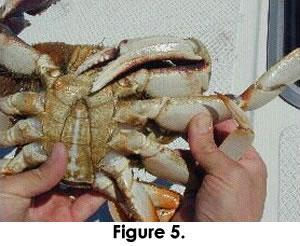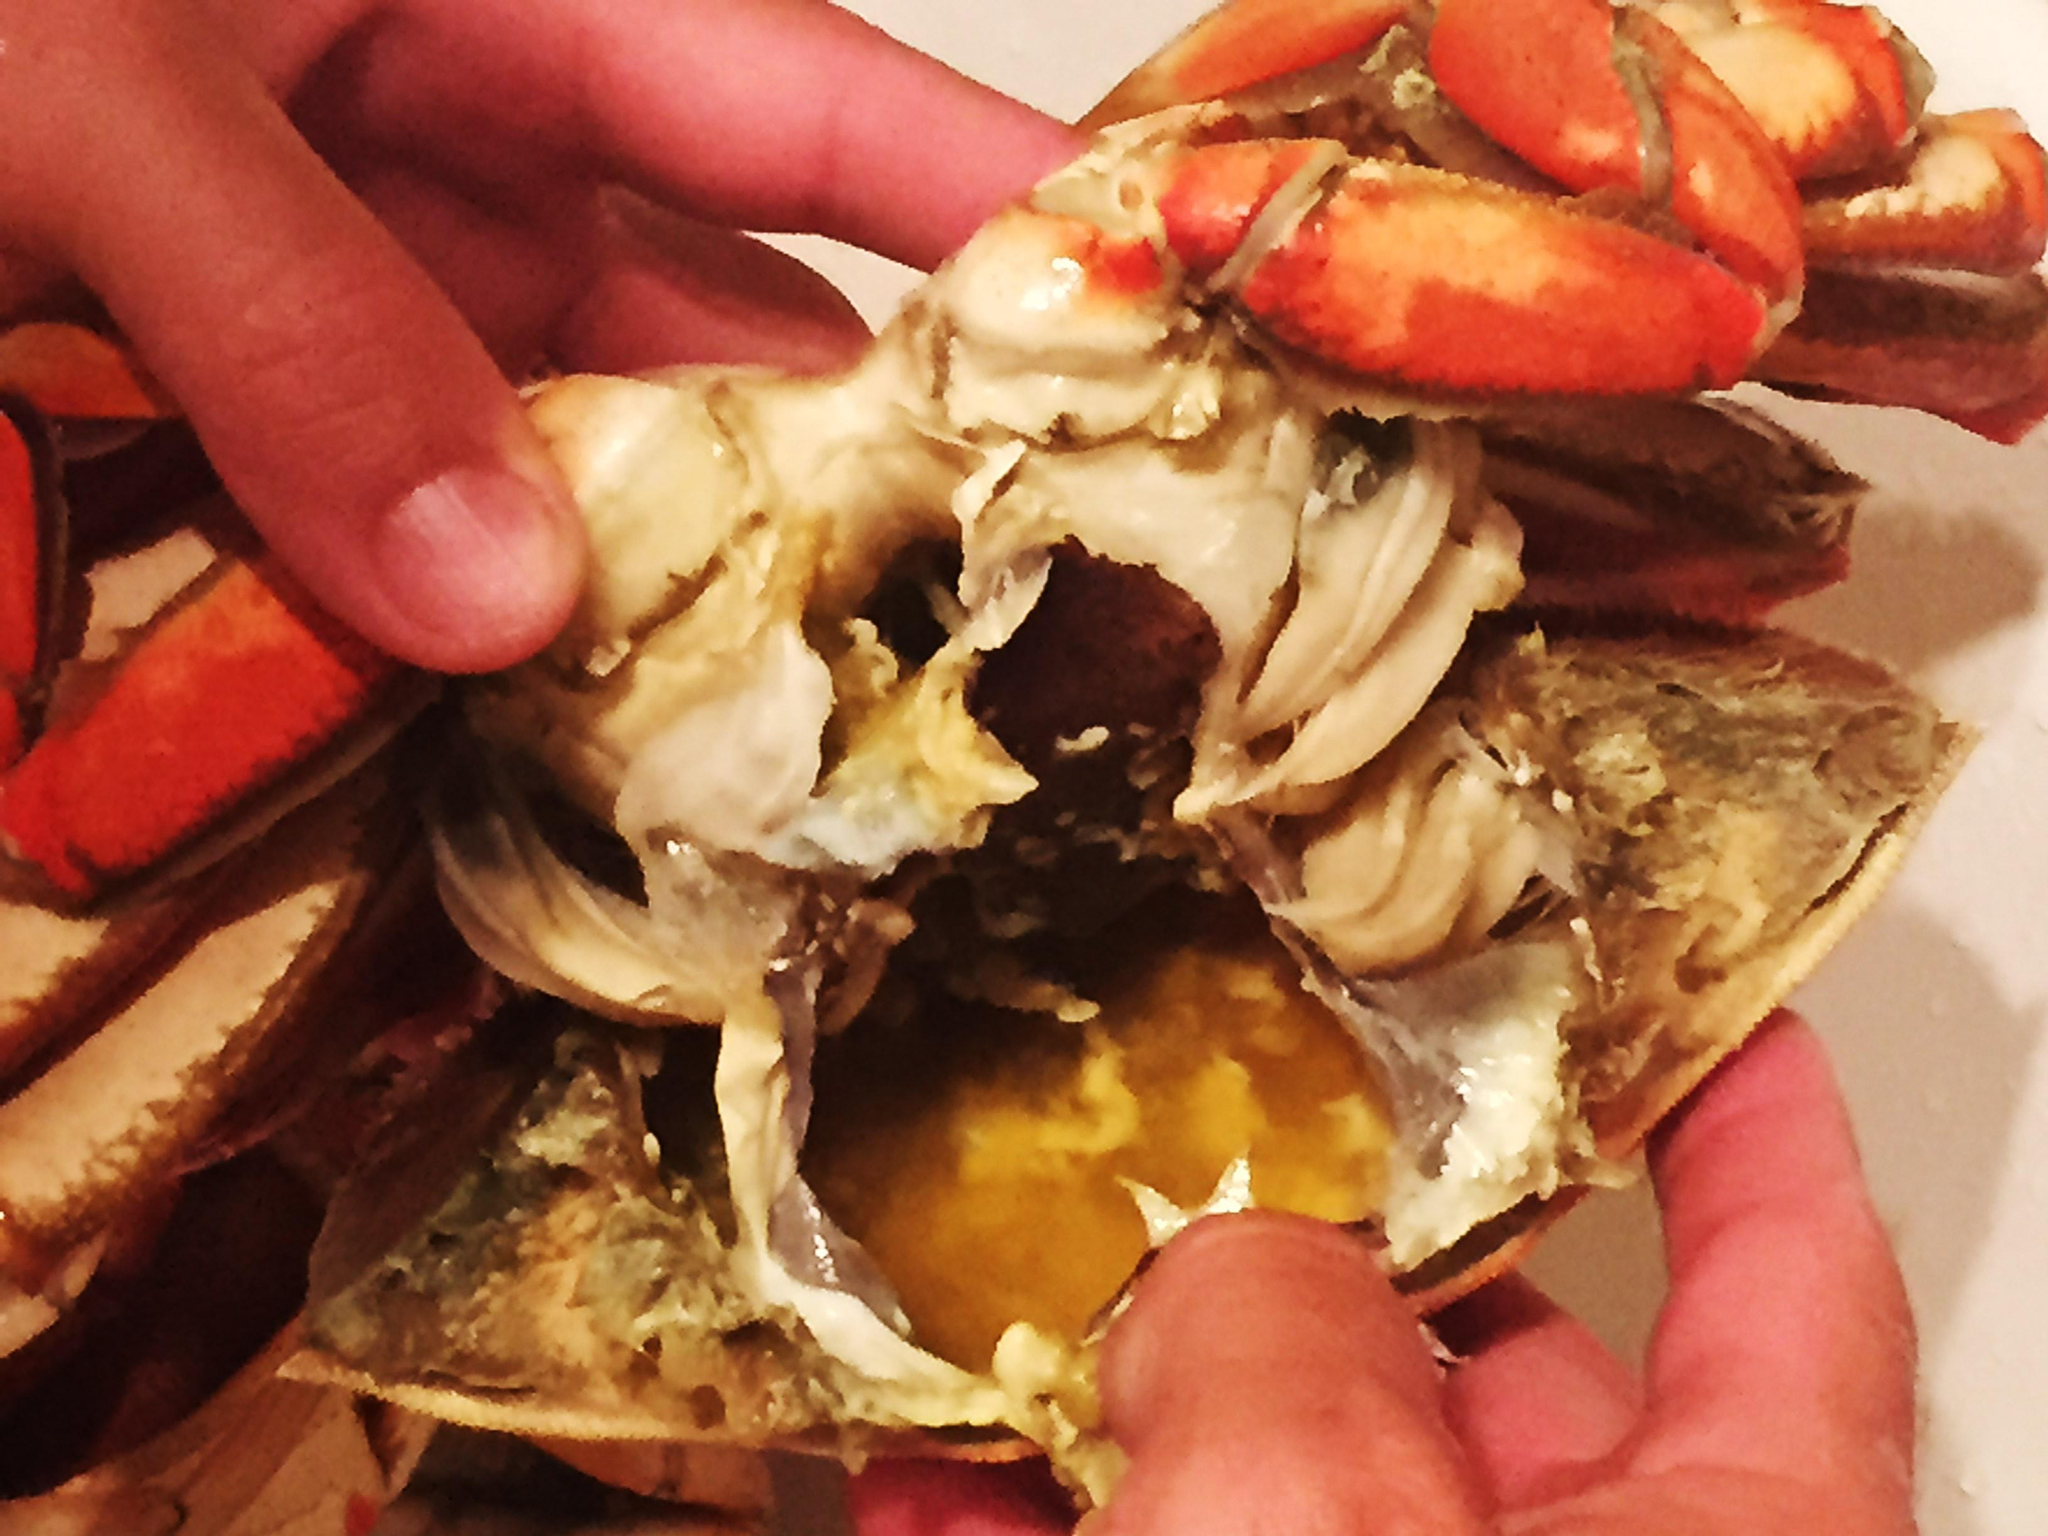The first image is the image on the left, the second image is the image on the right. Considering the images on both sides, is "Each crab sits on a sandy surface." valid? Answer yes or no. No. The first image is the image on the left, the second image is the image on the right. Assess this claim about the two images: "there are two crab sheels on the sand in the image pair". Correct or not? Answer yes or no. No. 